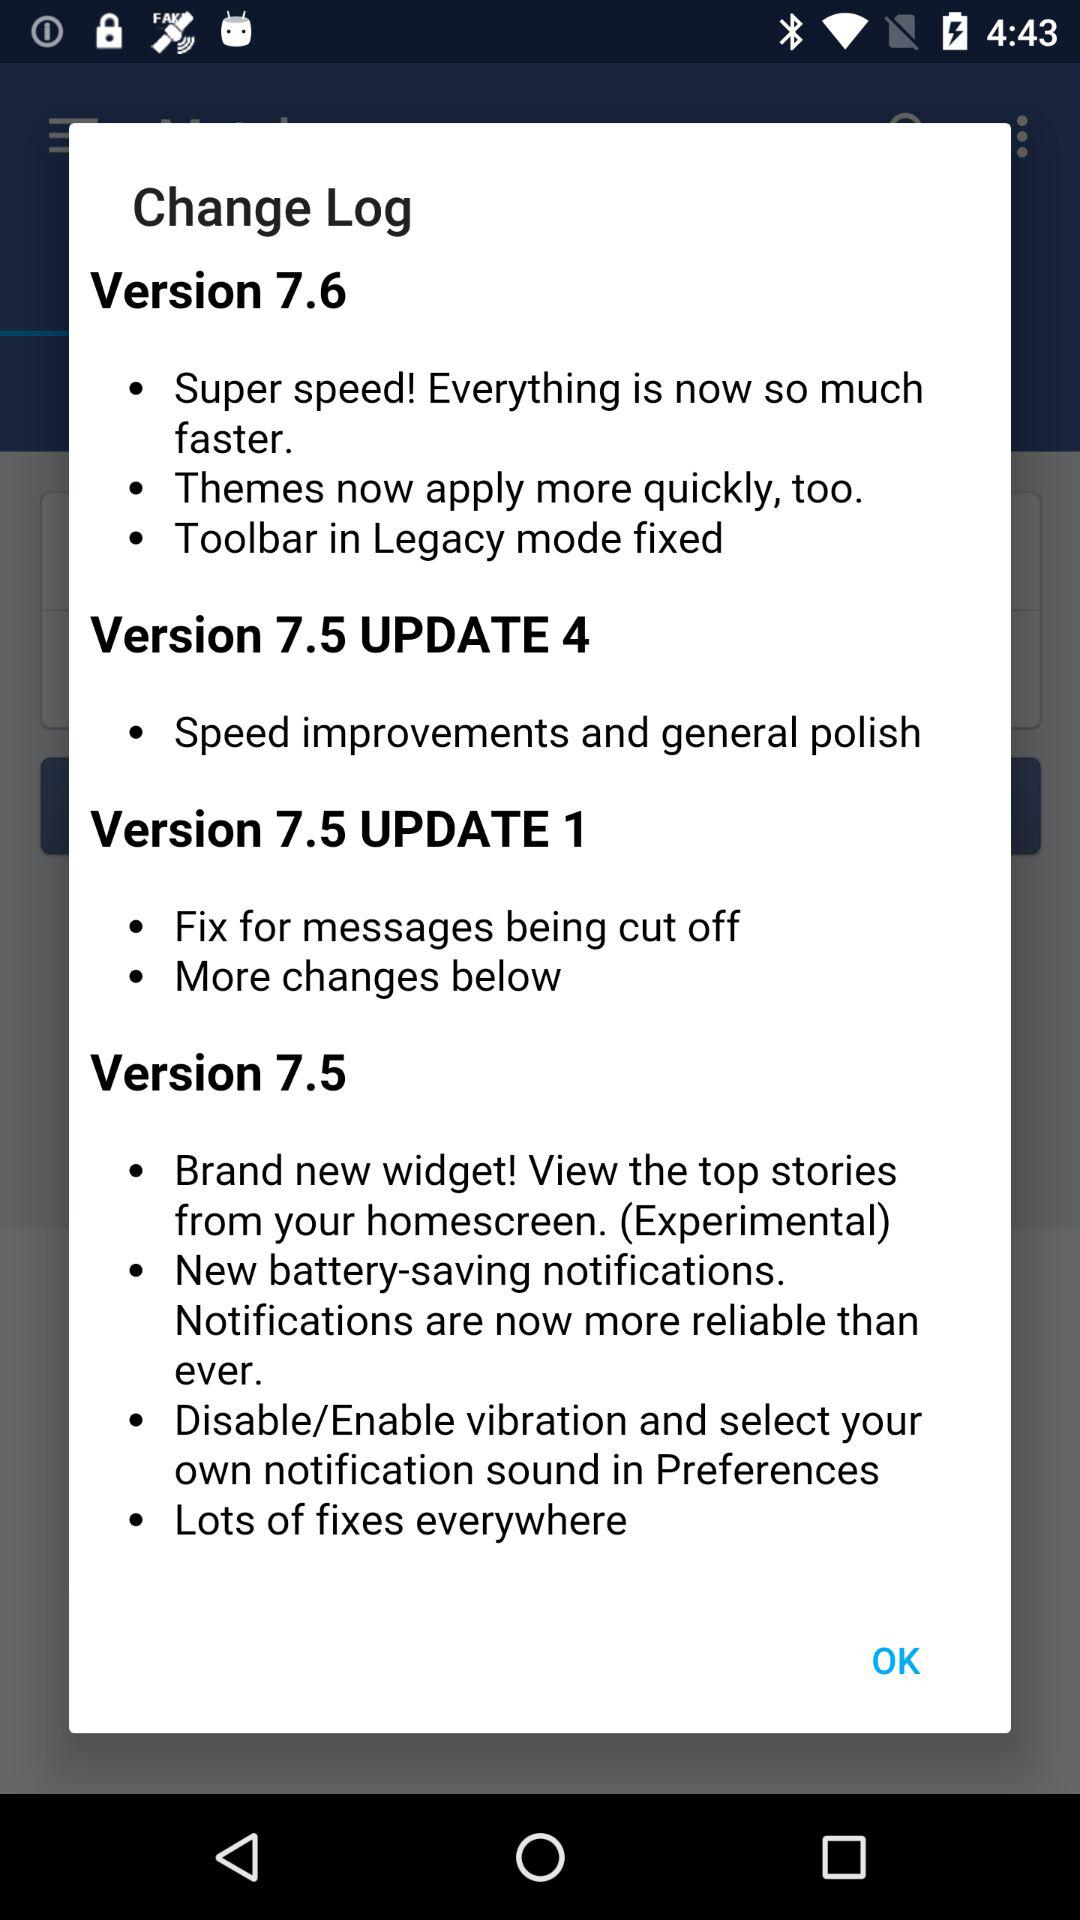In what version is the update of "Toolbar in Legacy mode fixed"? The version is 7.6. 